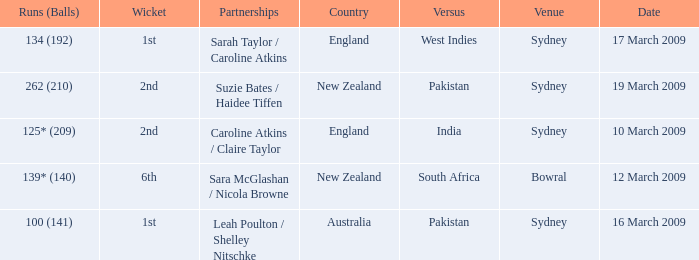How many times was the opponent country India?  1.0. 